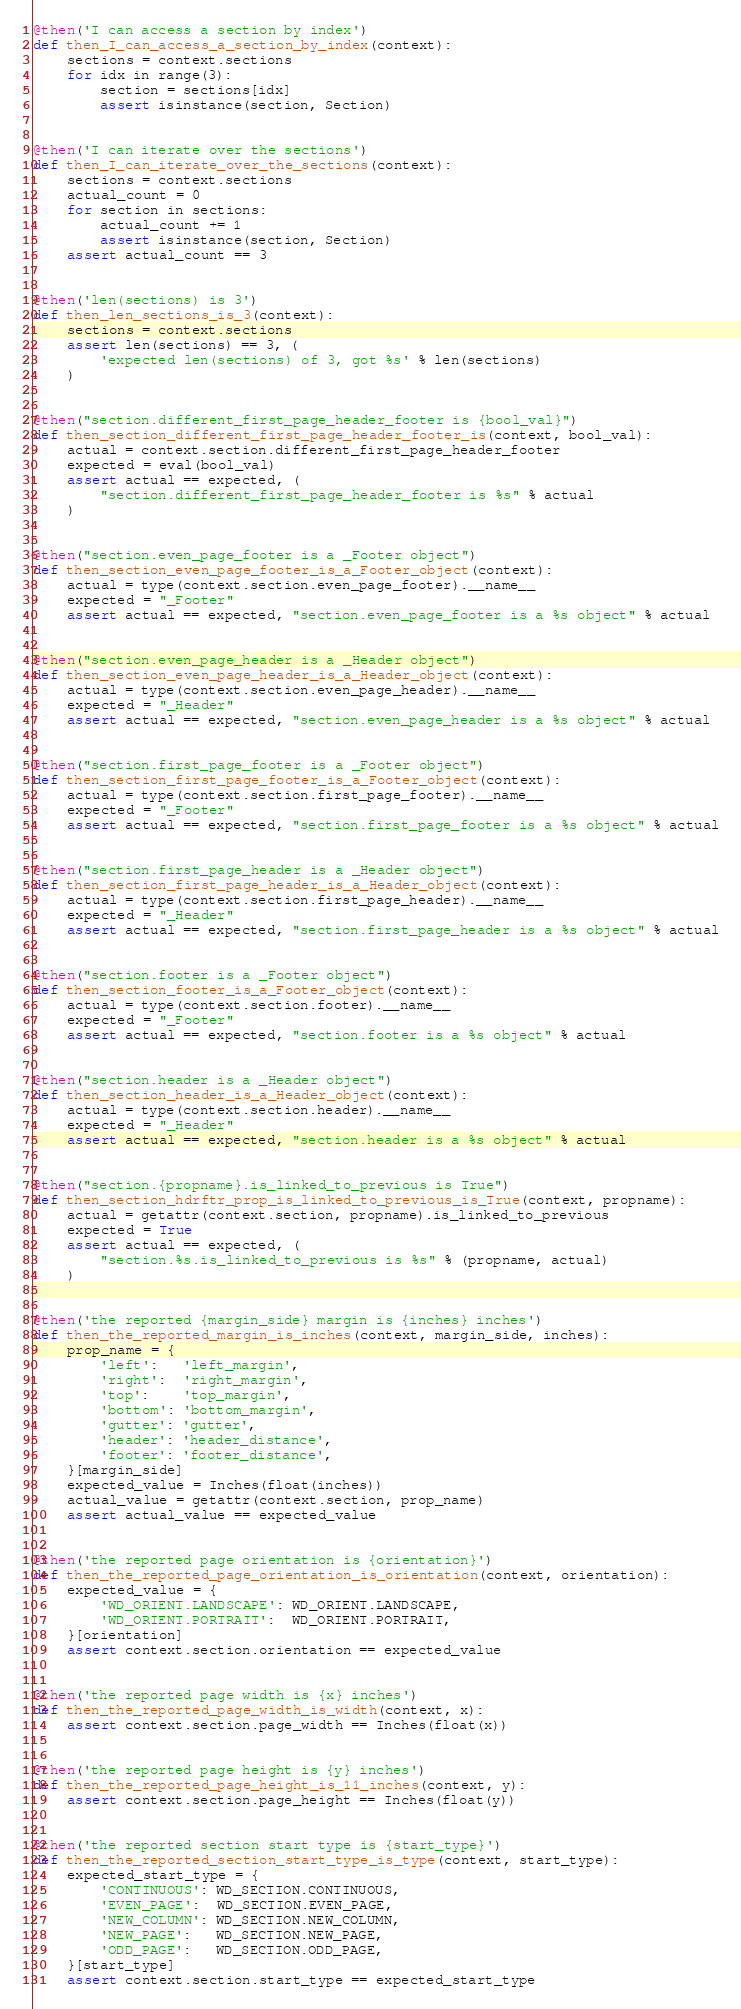Convert code to text. <code><loc_0><loc_0><loc_500><loc_500><_Python_>@then('I can access a section by index')
def then_I_can_access_a_section_by_index(context):
    sections = context.sections
    for idx in range(3):
        section = sections[idx]
        assert isinstance(section, Section)


@then('I can iterate over the sections')
def then_I_can_iterate_over_the_sections(context):
    sections = context.sections
    actual_count = 0
    for section in sections:
        actual_count += 1
        assert isinstance(section, Section)
    assert actual_count == 3


@then('len(sections) is 3')
def then_len_sections_is_3(context):
    sections = context.sections
    assert len(sections) == 3, (
        'expected len(sections) of 3, got %s' % len(sections)
    )


@then("section.different_first_page_header_footer is {bool_val}")
def then_section_different_first_page_header_footer_is(context, bool_val):
    actual = context.section.different_first_page_header_footer
    expected = eval(bool_val)
    assert actual == expected, (
        "section.different_first_page_header_footer is %s" % actual
    )


@then("section.even_page_footer is a _Footer object")
def then_section_even_page_footer_is_a_Footer_object(context):
    actual = type(context.section.even_page_footer).__name__
    expected = "_Footer"
    assert actual == expected, "section.even_page_footer is a %s object" % actual


@then("section.even_page_header is a _Header object")
def then_section_even_page_header_is_a_Header_object(context):
    actual = type(context.section.even_page_header).__name__
    expected = "_Header"
    assert actual == expected, "section.even_page_header is a %s object" % actual


@then("section.first_page_footer is a _Footer object")
def then_section_first_page_footer_is_a_Footer_object(context):
    actual = type(context.section.first_page_footer).__name__
    expected = "_Footer"
    assert actual == expected, "section.first_page_footer is a %s object" % actual


@then("section.first_page_header is a _Header object")
def then_section_first_page_header_is_a_Header_object(context):
    actual = type(context.section.first_page_header).__name__
    expected = "_Header"
    assert actual == expected, "section.first_page_header is a %s object" % actual


@then("section.footer is a _Footer object")
def then_section_footer_is_a_Footer_object(context):
    actual = type(context.section.footer).__name__
    expected = "_Footer"
    assert actual == expected, "section.footer is a %s object" % actual


@then("section.header is a _Header object")
def then_section_header_is_a_Header_object(context):
    actual = type(context.section.header).__name__
    expected = "_Header"
    assert actual == expected, "section.header is a %s object" % actual


@then("section.{propname}.is_linked_to_previous is True")
def then_section_hdrftr_prop_is_linked_to_previous_is_True(context, propname):
    actual = getattr(context.section, propname).is_linked_to_previous
    expected = True
    assert actual == expected, (
        "section.%s.is_linked_to_previous is %s" % (propname, actual)
    )


@then('the reported {margin_side} margin is {inches} inches')
def then_the_reported_margin_is_inches(context, margin_side, inches):
    prop_name = {
        'left':   'left_margin',
        'right':  'right_margin',
        'top':    'top_margin',
        'bottom': 'bottom_margin',
        'gutter': 'gutter',
        'header': 'header_distance',
        'footer': 'footer_distance',
    }[margin_side]
    expected_value = Inches(float(inches))
    actual_value = getattr(context.section, prop_name)
    assert actual_value == expected_value


@then('the reported page orientation is {orientation}')
def then_the_reported_page_orientation_is_orientation(context, orientation):
    expected_value = {
        'WD_ORIENT.LANDSCAPE': WD_ORIENT.LANDSCAPE,
        'WD_ORIENT.PORTRAIT':  WD_ORIENT.PORTRAIT,
    }[orientation]
    assert context.section.orientation == expected_value


@then('the reported page width is {x} inches')
def then_the_reported_page_width_is_width(context, x):
    assert context.section.page_width == Inches(float(x))


@then('the reported page height is {y} inches')
def then_the_reported_page_height_is_11_inches(context, y):
    assert context.section.page_height == Inches(float(y))


@then('the reported section start type is {start_type}')
def then_the_reported_section_start_type_is_type(context, start_type):
    expected_start_type = {
        'CONTINUOUS': WD_SECTION.CONTINUOUS,
        'EVEN_PAGE':  WD_SECTION.EVEN_PAGE,
        'NEW_COLUMN': WD_SECTION.NEW_COLUMN,
        'NEW_PAGE':   WD_SECTION.NEW_PAGE,
        'ODD_PAGE':   WD_SECTION.ODD_PAGE,
    }[start_type]
    assert context.section.start_type == expected_start_type
</code> 